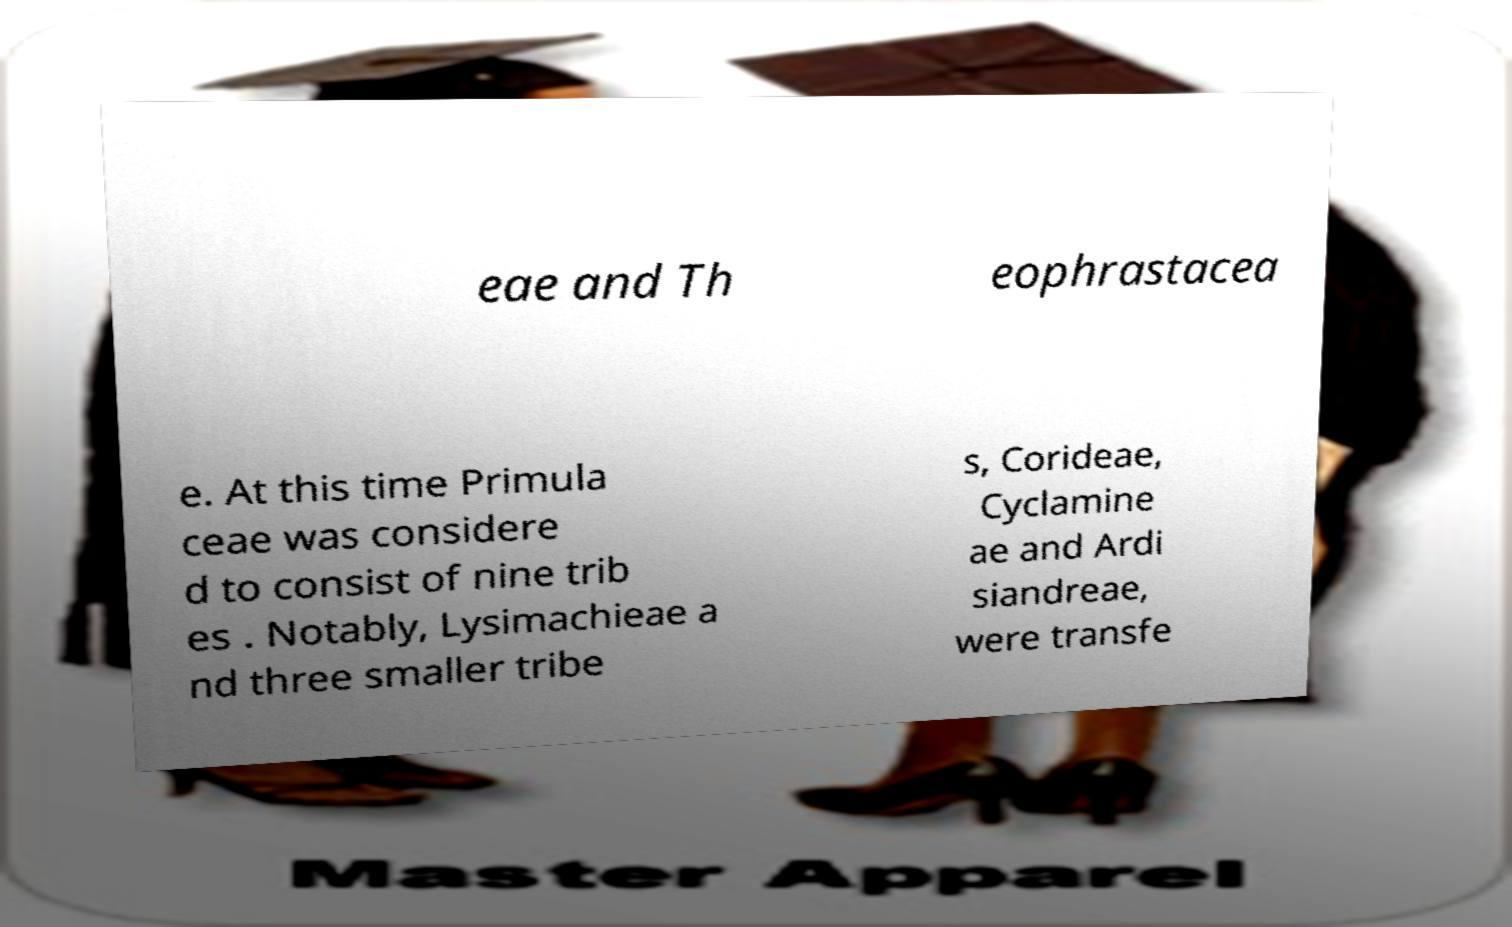Please read and relay the text visible in this image. What does it say? eae and Th eophrastacea e. At this time Primula ceae was considere d to consist of nine trib es . Notably, Lysimachieae a nd three smaller tribe s, Corideae, Cyclamine ae and Ardi siandreae, were transfe 